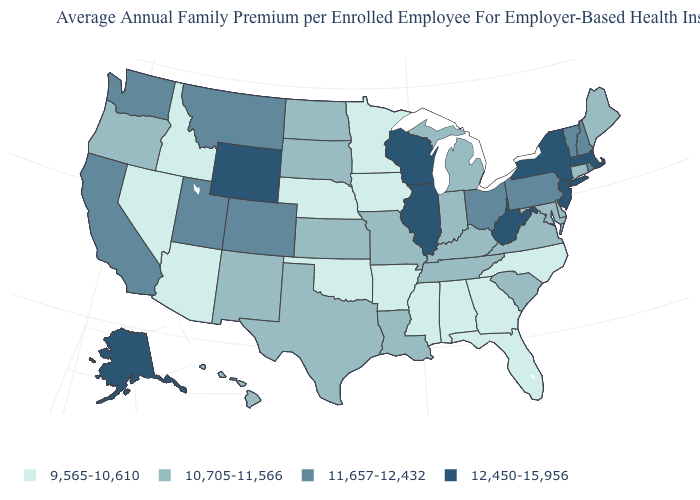Does Massachusetts have the highest value in the Northeast?
Quick response, please. Yes. Among the states that border Idaho , which have the lowest value?
Quick response, please. Nevada. What is the value of North Carolina?
Quick response, please. 9,565-10,610. Which states hav the highest value in the MidWest?
Be succinct. Illinois, Wisconsin. What is the value of New Hampshire?
Keep it brief. 11,657-12,432. Does Maine have the lowest value in the USA?
Write a very short answer. No. What is the value of Washington?
Quick response, please. 11,657-12,432. Does the map have missing data?
Be succinct. No. What is the value of Idaho?
Be succinct. 9,565-10,610. Does Alabama have a lower value than Florida?
Be succinct. No. Does Alaska have the lowest value in the USA?
Short answer required. No. What is the lowest value in the West?
Keep it brief. 9,565-10,610. What is the value of Maine?
Write a very short answer. 10,705-11,566. How many symbols are there in the legend?
Answer briefly. 4. Name the states that have a value in the range 9,565-10,610?
Short answer required. Alabama, Arizona, Arkansas, Florida, Georgia, Idaho, Iowa, Minnesota, Mississippi, Nebraska, Nevada, North Carolina, Oklahoma. 